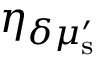<formula> <loc_0><loc_0><loc_500><loc_500>\eta _ { \delta \mu _ { s } ^ { \prime } }</formula> 